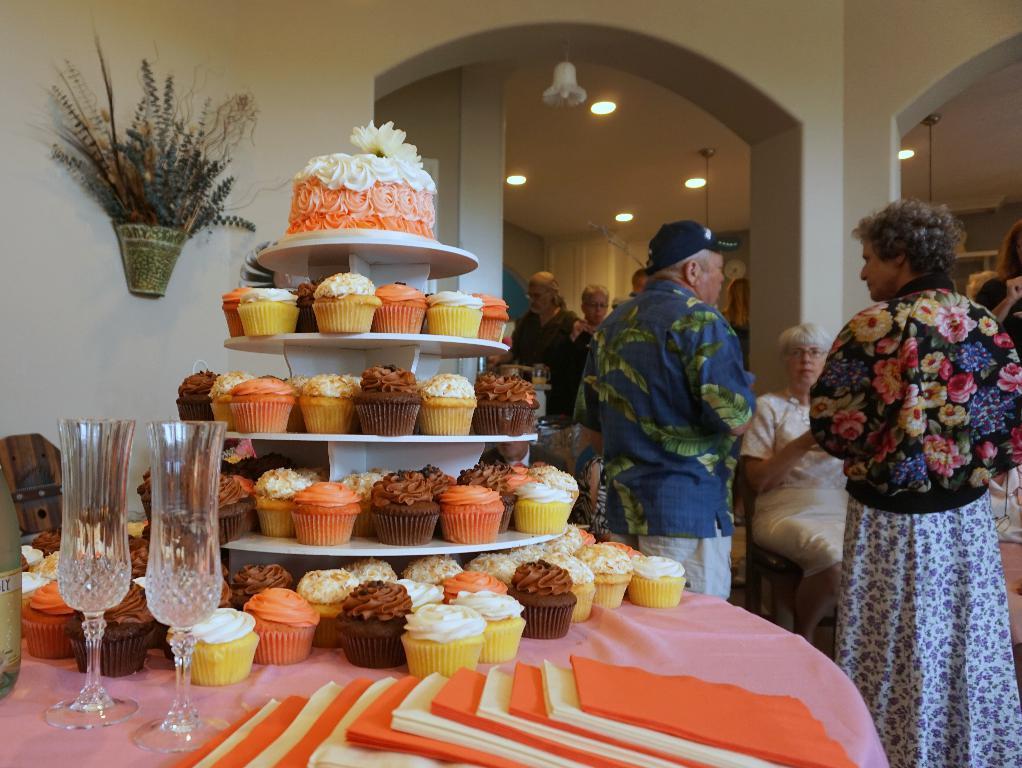Can you describe this image briefly? In this image in the foreground there is one table, on the table there are some cupcakes and glasses. In the background there are some people who are standing and some of them are sitting and also there are some pillars curtains. On the top there is ceiling and some lights, on the left side there is a wall. On the wall there is one basket. 